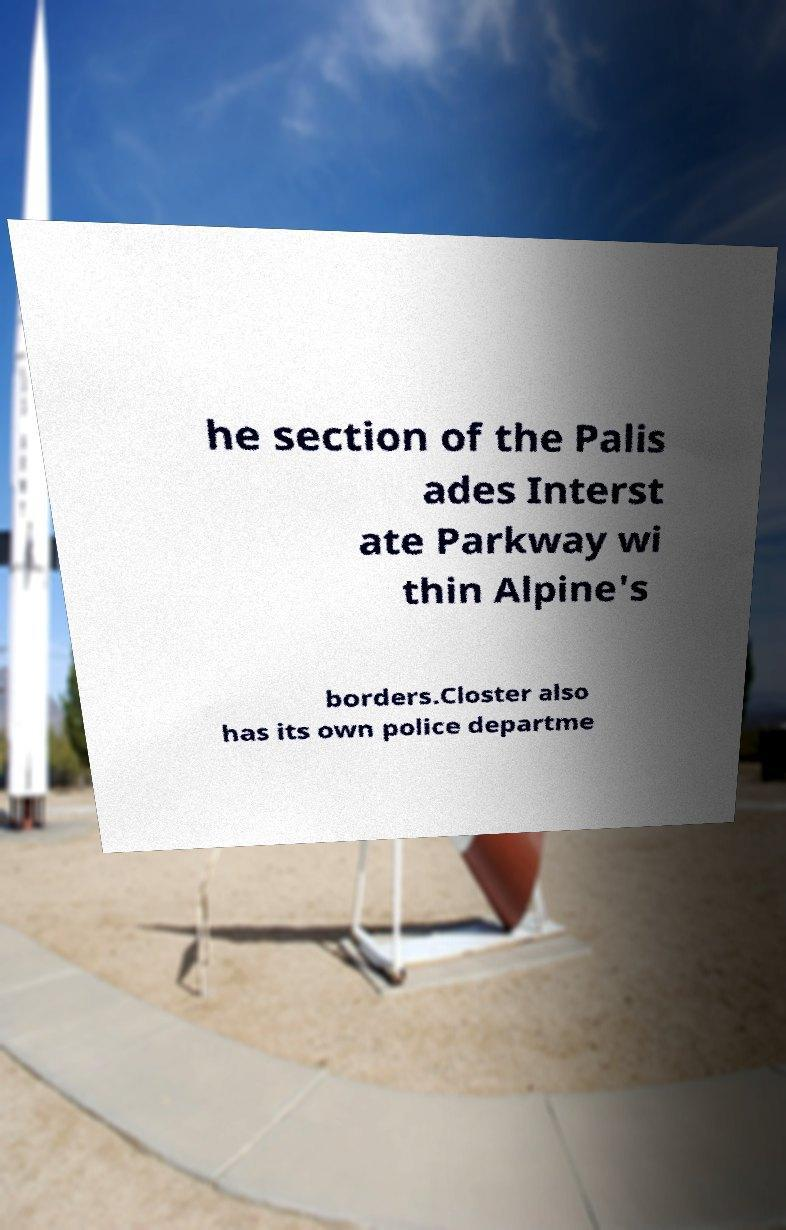Please identify and transcribe the text found in this image. he section of the Palis ades Interst ate Parkway wi thin Alpine's borders.Closter also has its own police departme 